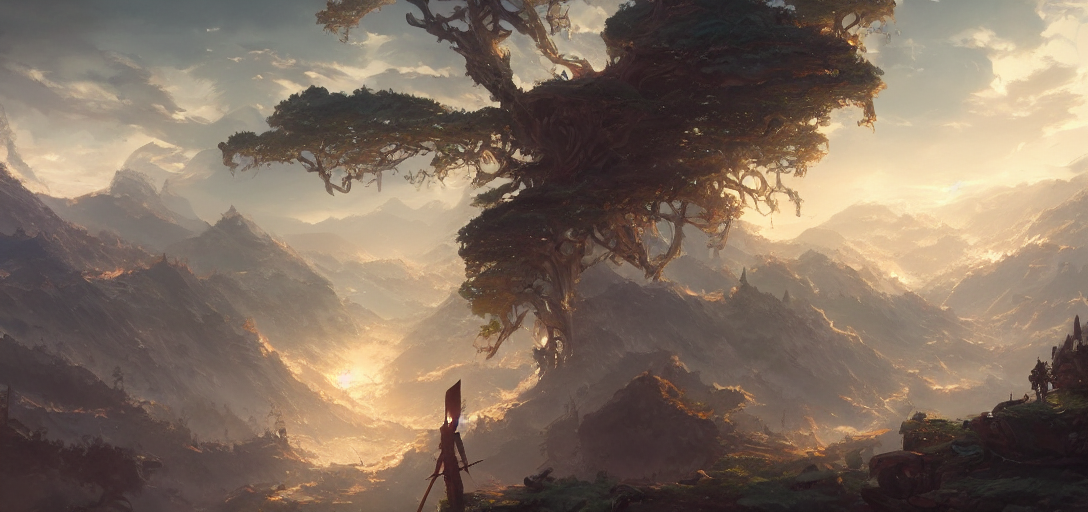What sort of climate or environment does this image suggest? The image suggests a temperate to warm climate, given the presence of lush greenery and the warm, soft light. The environment appears to be a mix of rugged mountains and fertile land, indicative of a diverse and thriving ecosystem. 